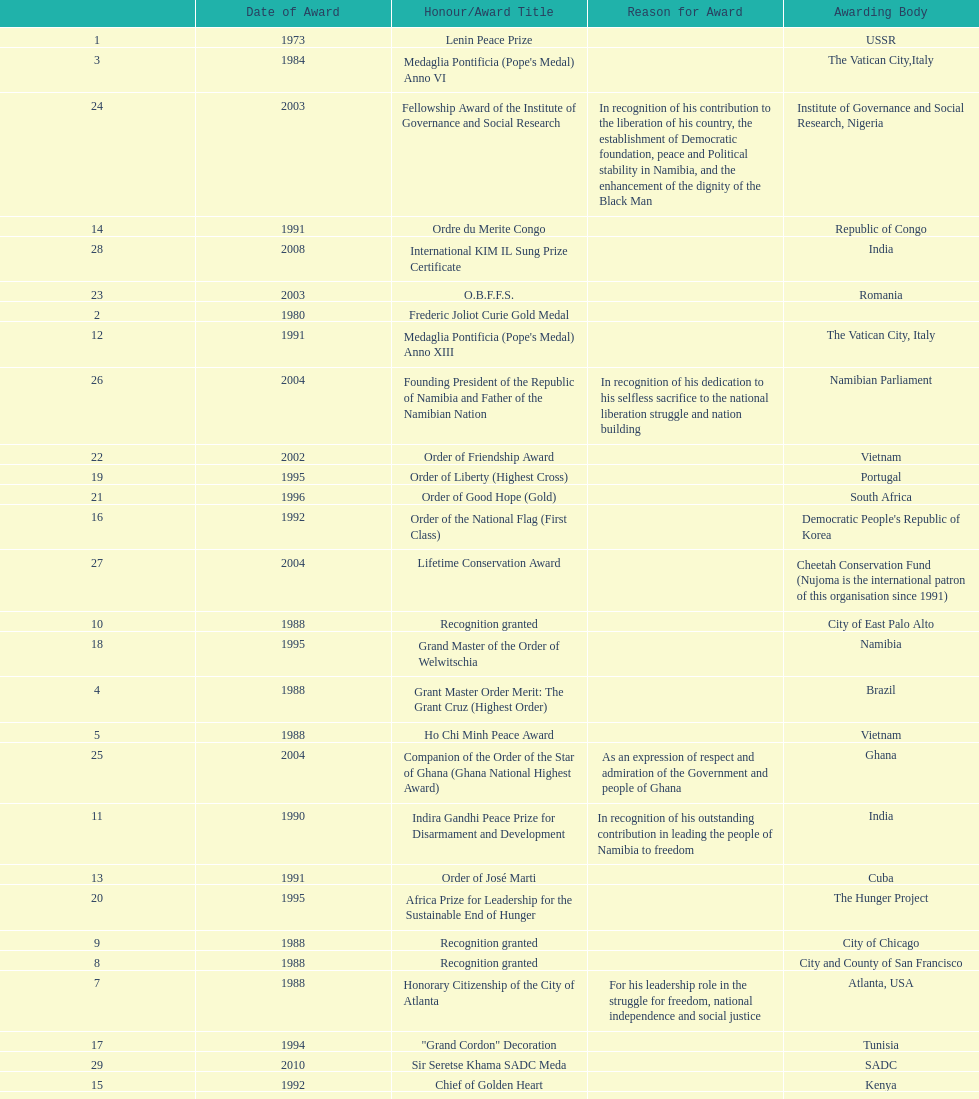What is the most recent award nujoma received? Sir Seretse Khama SADC Meda. 